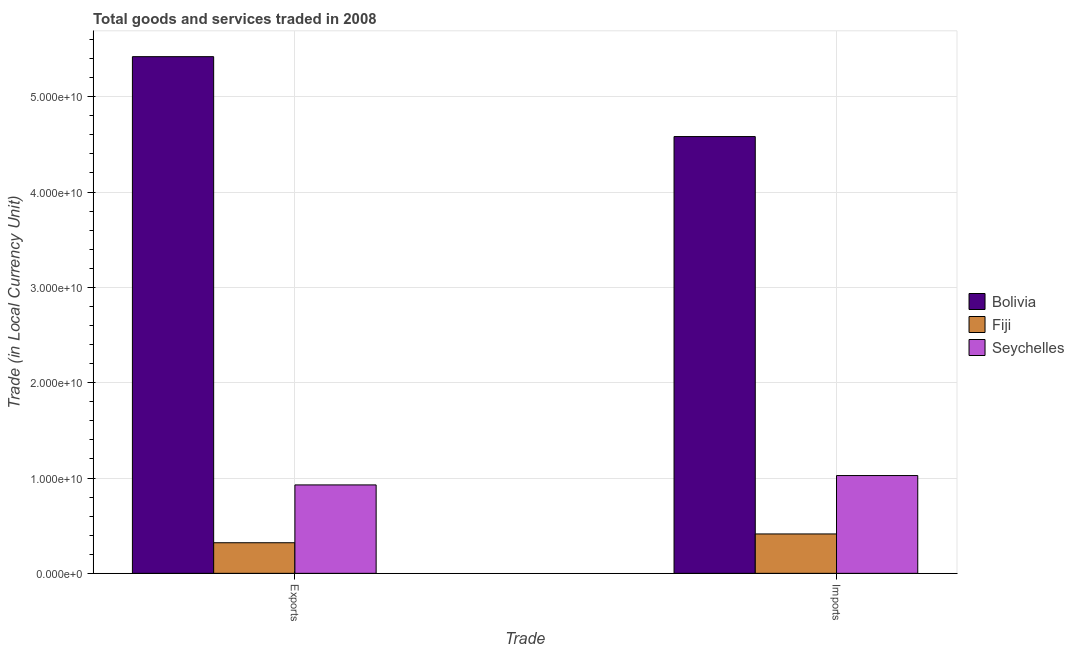How many groups of bars are there?
Your answer should be very brief. 2. How many bars are there on the 2nd tick from the left?
Provide a short and direct response. 3. How many bars are there on the 1st tick from the right?
Your answer should be compact. 3. What is the label of the 2nd group of bars from the left?
Your answer should be very brief. Imports. What is the export of goods and services in Bolivia?
Keep it short and to the point. 5.42e+1. Across all countries, what is the maximum export of goods and services?
Give a very brief answer. 5.42e+1. Across all countries, what is the minimum imports of goods and services?
Your answer should be very brief. 4.13e+09. In which country was the imports of goods and services minimum?
Your answer should be compact. Fiji. What is the total imports of goods and services in the graph?
Offer a terse response. 6.02e+1. What is the difference between the imports of goods and services in Fiji and that in Bolivia?
Ensure brevity in your answer.  -4.17e+1. What is the difference between the imports of goods and services in Fiji and the export of goods and services in Bolivia?
Offer a terse response. -5.01e+1. What is the average imports of goods and services per country?
Ensure brevity in your answer.  2.01e+1. What is the difference between the imports of goods and services and export of goods and services in Seychelles?
Ensure brevity in your answer.  9.82e+08. In how many countries, is the imports of goods and services greater than 24000000000 LCU?
Your answer should be very brief. 1. What is the ratio of the imports of goods and services in Bolivia to that in Seychelles?
Offer a terse response. 4.47. In how many countries, is the imports of goods and services greater than the average imports of goods and services taken over all countries?
Your answer should be very brief. 1. What does the 3rd bar from the right in Imports represents?
Your answer should be compact. Bolivia. Are all the bars in the graph horizontal?
Give a very brief answer. No. What is the difference between two consecutive major ticks on the Y-axis?
Make the answer very short. 1.00e+1. Does the graph contain grids?
Your answer should be compact. Yes. Where does the legend appear in the graph?
Ensure brevity in your answer.  Center right. How many legend labels are there?
Give a very brief answer. 3. What is the title of the graph?
Keep it short and to the point. Total goods and services traded in 2008. What is the label or title of the X-axis?
Your answer should be very brief. Trade. What is the label or title of the Y-axis?
Offer a terse response. Trade (in Local Currency Unit). What is the Trade (in Local Currency Unit) in Bolivia in Exports?
Offer a terse response. 5.42e+1. What is the Trade (in Local Currency Unit) of Fiji in Exports?
Provide a succinct answer. 3.21e+09. What is the Trade (in Local Currency Unit) of Seychelles in Exports?
Your answer should be very brief. 9.27e+09. What is the Trade (in Local Currency Unit) in Bolivia in Imports?
Offer a terse response. 4.58e+1. What is the Trade (in Local Currency Unit) of Fiji in Imports?
Offer a very short reply. 4.13e+09. What is the Trade (in Local Currency Unit) of Seychelles in Imports?
Keep it short and to the point. 1.03e+1. Across all Trade, what is the maximum Trade (in Local Currency Unit) of Bolivia?
Provide a short and direct response. 5.42e+1. Across all Trade, what is the maximum Trade (in Local Currency Unit) in Fiji?
Offer a terse response. 4.13e+09. Across all Trade, what is the maximum Trade (in Local Currency Unit) of Seychelles?
Give a very brief answer. 1.03e+1. Across all Trade, what is the minimum Trade (in Local Currency Unit) in Bolivia?
Provide a short and direct response. 4.58e+1. Across all Trade, what is the minimum Trade (in Local Currency Unit) of Fiji?
Give a very brief answer. 3.21e+09. Across all Trade, what is the minimum Trade (in Local Currency Unit) in Seychelles?
Your answer should be compact. 9.27e+09. What is the total Trade (in Local Currency Unit) in Bolivia in the graph?
Provide a succinct answer. 1.00e+11. What is the total Trade (in Local Currency Unit) in Fiji in the graph?
Give a very brief answer. 7.34e+09. What is the total Trade (in Local Currency Unit) of Seychelles in the graph?
Provide a short and direct response. 1.95e+1. What is the difference between the Trade (in Local Currency Unit) in Bolivia in Exports and that in Imports?
Make the answer very short. 8.38e+09. What is the difference between the Trade (in Local Currency Unit) of Fiji in Exports and that in Imports?
Your response must be concise. -9.23e+08. What is the difference between the Trade (in Local Currency Unit) of Seychelles in Exports and that in Imports?
Keep it short and to the point. -9.82e+08. What is the difference between the Trade (in Local Currency Unit) in Bolivia in Exports and the Trade (in Local Currency Unit) in Fiji in Imports?
Give a very brief answer. 5.01e+1. What is the difference between the Trade (in Local Currency Unit) of Bolivia in Exports and the Trade (in Local Currency Unit) of Seychelles in Imports?
Give a very brief answer. 4.39e+1. What is the difference between the Trade (in Local Currency Unit) in Fiji in Exports and the Trade (in Local Currency Unit) in Seychelles in Imports?
Your answer should be very brief. -7.05e+09. What is the average Trade (in Local Currency Unit) in Bolivia per Trade?
Offer a terse response. 5.00e+1. What is the average Trade (in Local Currency Unit) in Fiji per Trade?
Your answer should be compact. 3.67e+09. What is the average Trade (in Local Currency Unit) in Seychelles per Trade?
Provide a succinct answer. 9.77e+09. What is the difference between the Trade (in Local Currency Unit) of Bolivia and Trade (in Local Currency Unit) of Fiji in Exports?
Your answer should be very brief. 5.10e+1. What is the difference between the Trade (in Local Currency Unit) in Bolivia and Trade (in Local Currency Unit) in Seychelles in Exports?
Make the answer very short. 4.49e+1. What is the difference between the Trade (in Local Currency Unit) of Fiji and Trade (in Local Currency Unit) of Seychelles in Exports?
Offer a terse response. -6.07e+09. What is the difference between the Trade (in Local Currency Unit) in Bolivia and Trade (in Local Currency Unit) in Fiji in Imports?
Your answer should be very brief. 4.17e+1. What is the difference between the Trade (in Local Currency Unit) in Bolivia and Trade (in Local Currency Unit) in Seychelles in Imports?
Give a very brief answer. 3.56e+1. What is the difference between the Trade (in Local Currency Unit) in Fiji and Trade (in Local Currency Unit) in Seychelles in Imports?
Keep it short and to the point. -6.12e+09. What is the ratio of the Trade (in Local Currency Unit) in Bolivia in Exports to that in Imports?
Provide a succinct answer. 1.18. What is the ratio of the Trade (in Local Currency Unit) in Fiji in Exports to that in Imports?
Provide a succinct answer. 0.78. What is the ratio of the Trade (in Local Currency Unit) in Seychelles in Exports to that in Imports?
Provide a short and direct response. 0.9. What is the difference between the highest and the second highest Trade (in Local Currency Unit) of Bolivia?
Provide a short and direct response. 8.38e+09. What is the difference between the highest and the second highest Trade (in Local Currency Unit) of Fiji?
Your answer should be compact. 9.23e+08. What is the difference between the highest and the second highest Trade (in Local Currency Unit) of Seychelles?
Offer a terse response. 9.82e+08. What is the difference between the highest and the lowest Trade (in Local Currency Unit) of Bolivia?
Keep it short and to the point. 8.38e+09. What is the difference between the highest and the lowest Trade (in Local Currency Unit) in Fiji?
Provide a short and direct response. 9.23e+08. What is the difference between the highest and the lowest Trade (in Local Currency Unit) of Seychelles?
Offer a very short reply. 9.82e+08. 